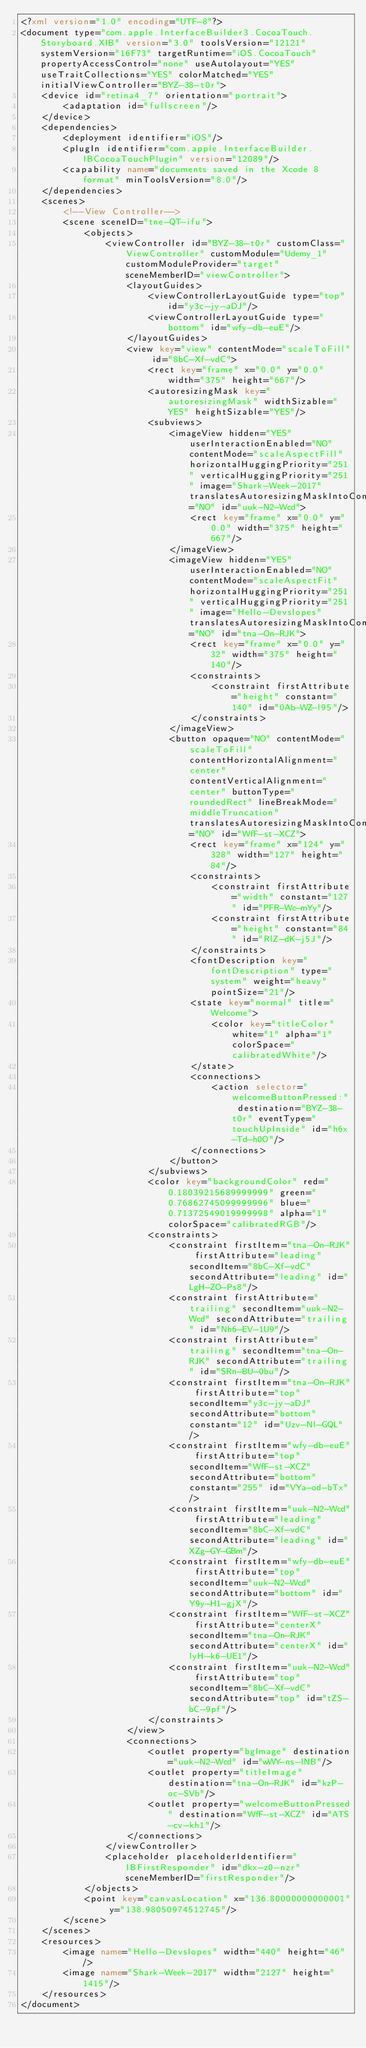<code> <loc_0><loc_0><loc_500><loc_500><_XML_><?xml version="1.0" encoding="UTF-8"?>
<document type="com.apple.InterfaceBuilder3.CocoaTouch.Storyboard.XIB" version="3.0" toolsVersion="12121" systemVersion="16F73" targetRuntime="iOS.CocoaTouch" propertyAccessControl="none" useAutolayout="YES" useTraitCollections="YES" colorMatched="YES" initialViewController="BYZ-38-t0r">
    <device id="retina4_7" orientation="portrait">
        <adaptation id="fullscreen"/>
    </device>
    <dependencies>
        <deployment identifier="iOS"/>
        <plugIn identifier="com.apple.InterfaceBuilder.IBCocoaTouchPlugin" version="12089"/>
        <capability name="documents saved in the Xcode 8 format" minToolsVersion="8.0"/>
    </dependencies>
    <scenes>
        <!--View Controller-->
        <scene sceneID="tne-QT-ifu">
            <objects>
                <viewController id="BYZ-38-t0r" customClass="ViewController" customModule="Udemy_1" customModuleProvider="target" sceneMemberID="viewController">
                    <layoutGuides>
                        <viewControllerLayoutGuide type="top" id="y3c-jy-aDJ"/>
                        <viewControllerLayoutGuide type="bottom" id="wfy-db-euE"/>
                    </layoutGuides>
                    <view key="view" contentMode="scaleToFill" id="8bC-Xf-vdC">
                        <rect key="frame" x="0.0" y="0.0" width="375" height="667"/>
                        <autoresizingMask key="autoresizingMask" widthSizable="YES" heightSizable="YES"/>
                        <subviews>
                            <imageView hidden="YES" userInteractionEnabled="NO" contentMode="scaleAspectFill" horizontalHuggingPriority="251" verticalHuggingPriority="251" image="Shark-Week-2017" translatesAutoresizingMaskIntoConstraints="NO" id="uuk-N2-Wcd">
                                <rect key="frame" x="0.0" y="0.0" width="375" height="667"/>
                            </imageView>
                            <imageView hidden="YES" userInteractionEnabled="NO" contentMode="scaleAspectFit" horizontalHuggingPriority="251" verticalHuggingPriority="251" image="Hello-Devslopes" translatesAutoresizingMaskIntoConstraints="NO" id="tna-On-RJK">
                                <rect key="frame" x="0.0" y="32" width="375" height="140"/>
                                <constraints>
                                    <constraint firstAttribute="height" constant="140" id="0Ab-WZ-l95"/>
                                </constraints>
                            </imageView>
                            <button opaque="NO" contentMode="scaleToFill" contentHorizontalAlignment="center" contentVerticalAlignment="center" buttonType="roundedRect" lineBreakMode="middleTruncation" translatesAutoresizingMaskIntoConstraints="NO" id="WfF-st-XCZ">
                                <rect key="frame" x="124" y="328" width="127" height="84"/>
                                <constraints>
                                    <constraint firstAttribute="width" constant="127" id="PFR-Wc-mYy"/>
                                    <constraint firstAttribute="height" constant="84" id="RlZ-dK-j5J"/>
                                </constraints>
                                <fontDescription key="fontDescription" type="system" weight="heavy" pointSize="21"/>
                                <state key="normal" title="Welcome">
                                    <color key="titleColor" white="1" alpha="1" colorSpace="calibratedWhite"/>
                                </state>
                                <connections>
                                    <action selector="welcomeButtonPressed:" destination="BYZ-38-t0r" eventType="touchUpInside" id="h6x-Td-h0O"/>
                                </connections>
                            </button>
                        </subviews>
                        <color key="backgroundColor" red="0.18039215689999999" green="0.76862745099999996" blue="0.71372549019999998" alpha="1" colorSpace="calibratedRGB"/>
                        <constraints>
                            <constraint firstItem="tna-On-RJK" firstAttribute="leading" secondItem="8bC-Xf-vdC" secondAttribute="leading" id="LgH-ZO-Ps8"/>
                            <constraint firstAttribute="trailing" secondItem="uuk-N2-Wcd" secondAttribute="trailing" id="Nh6-EV-1U9"/>
                            <constraint firstAttribute="trailing" secondItem="tna-On-RJK" secondAttribute="trailing" id="SRn-BU-0bu"/>
                            <constraint firstItem="tna-On-RJK" firstAttribute="top" secondItem="y3c-jy-aDJ" secondAttribute="bottom" constant="12" id="Uzv-Nl-GQL"/>
                            <constraint firstItem="wfy-db-euE" firstAttribute="top" secondItem="WfF-st-XCZ" secondAttribute="bottom" constant="255" id="VYa-od-bTx"/>
                            <constraint firstItem="uuk-N2-Wcd" firstAttribute="leading" secondItem="8bC-Xf-vdC" secondAttribute="leading" id="XZg-GY-GBm"/>
                            <constraint firstItem="wfy-db-euE" firstAttribute="top" secondItem="uuk-N2-Wcd" secondAttribute="bottom" id="Y9y-H1-gjX"/>
                            <constraint firstItem="WfF-st-XCZ" firstAttribute="centerX" secondItem="tna-On-RJK" secondAttribute="centerX" id="lyH-k6-UE1"/>
                            <constraint firstItem="uuk-N2-Wcd" firstAttribute="top" secondItem="8bC-Xf-vdC" secondAttribute="top" id="tZS-bC-9pf"/>
                        </constraints>
                    </view>
                    <connections>
                        <outlet property="bgImage" destination="uuk-N2-Wcd" id="wWY-ns-INB"/>
                        <outlet property="titleImage" destination="tna-On-RJK" id="kzP-oc-SVb"/>
                        <outlet property="welcomeButtonPressed" destination="WfF-st-XCZ" id="ATS-cv-kh1"/>
                    </connections>
                </viewController>
                <placeholder placeholderIdentifier="IBFirstResponder" id="dkx-z0-nzr" sceneMemberID="firstResponder"/>
            </objects>
            <point key="canvasLocation" x="136.80000000000001" y="138.98050974512745"/>
        </scene>
    </scenes>
    <resources>
        <image name="Hello-Devslopes" width="440" height="46"/>
        <image name="Shark-Week-2017" width="2127" height="1415"/>
    </resources>
</document>
</code> 